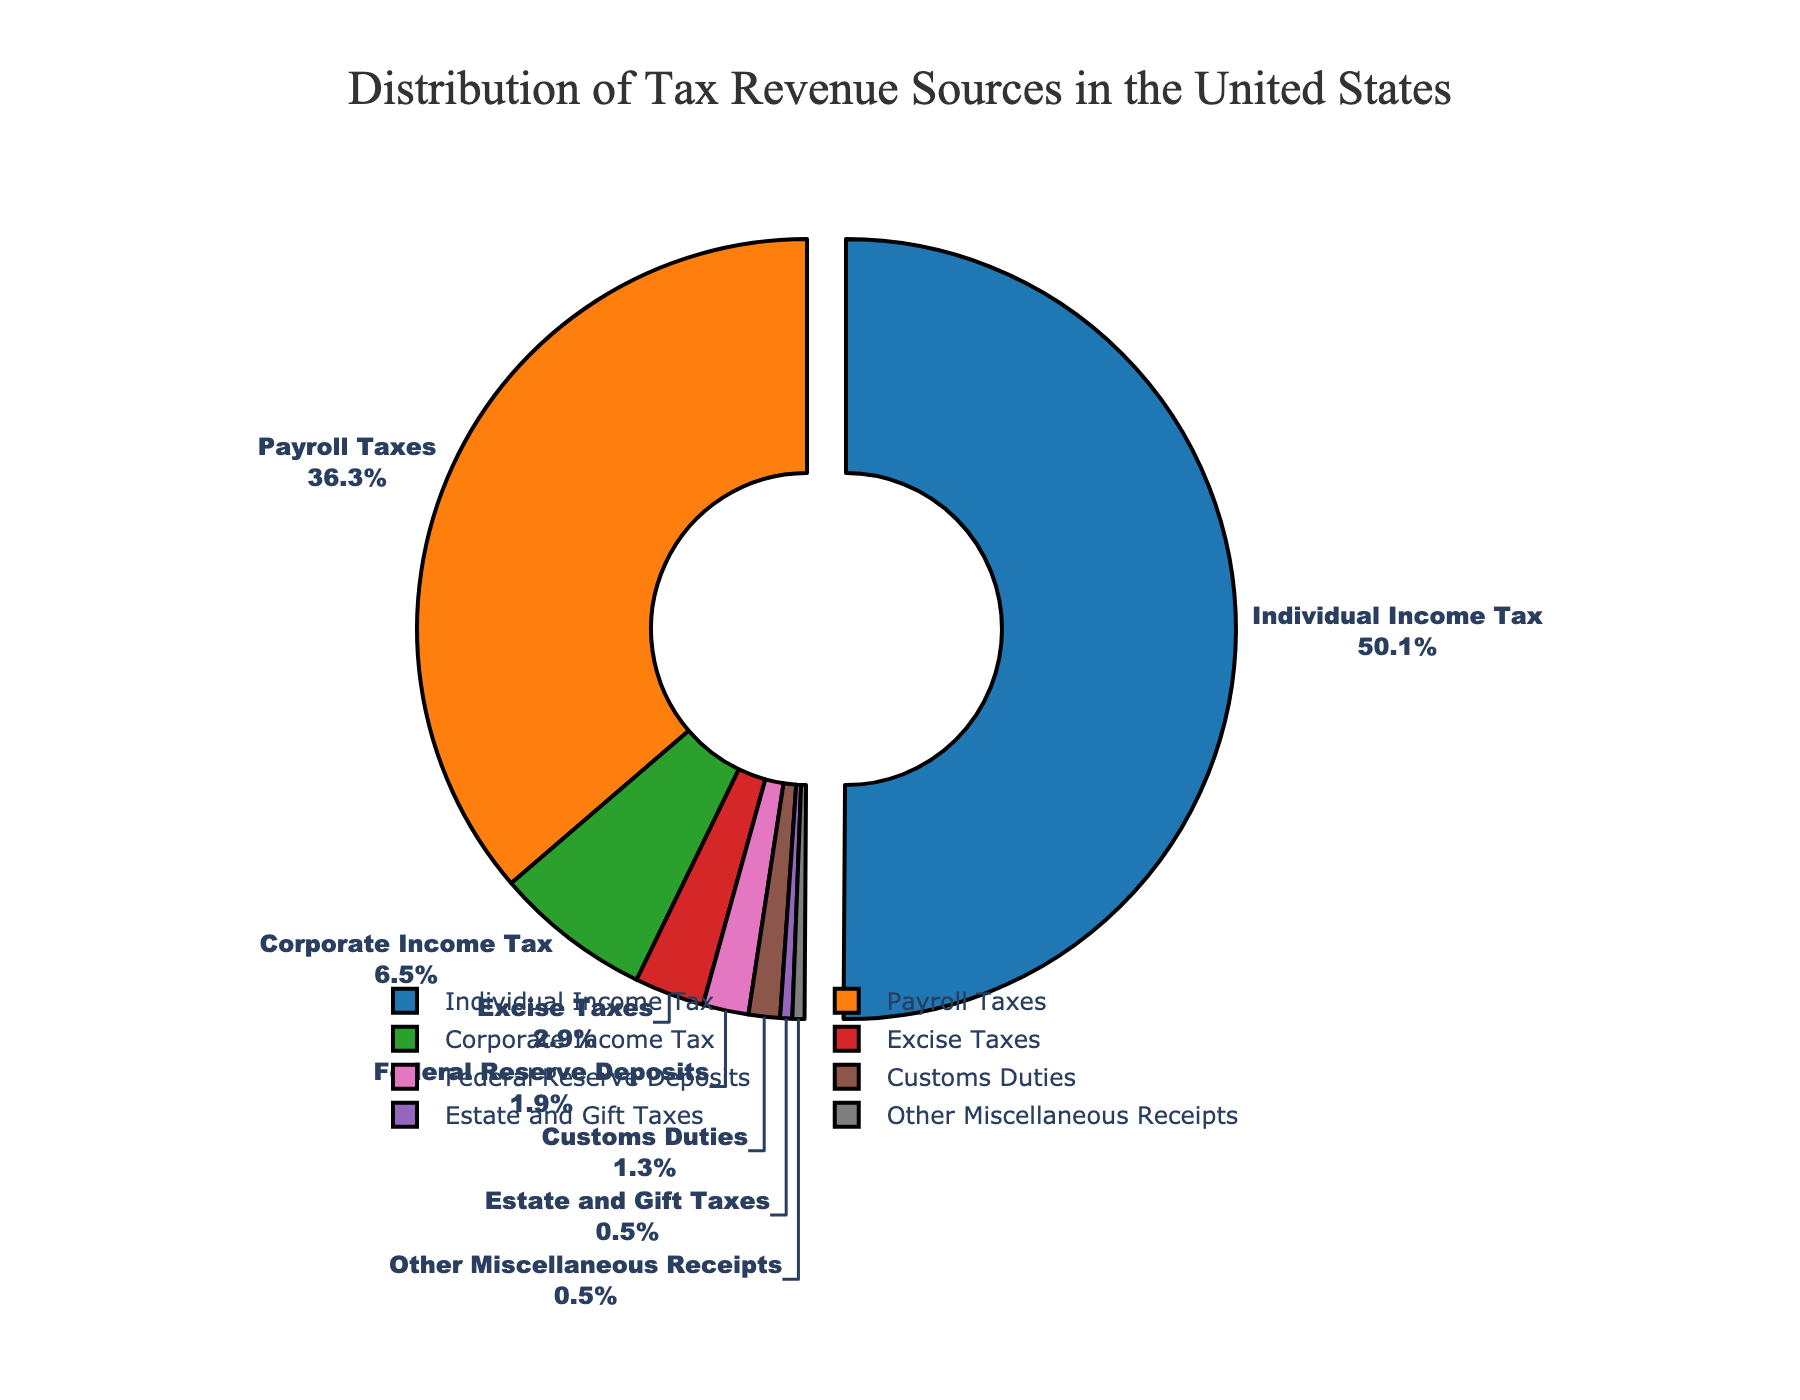What is the largest source of tax revenue? By referring to the pie chart, the segment with the largest portion will be the largest source. The 'Individual Income Tax' segment is visually the largest in the pie chart.
Answer: Individual Income Tax What percentage of tax revenue comes from Payroll Taxes? The visual information shows a segment labeled 'Payroll Taxes' with a percentage. This segment is 36.3%.
Answer: 36.3% How much larger is the Corporate Income Tax compared to Excise Taxes? Looking at the pie chart, find the segments for 'Corporate Income Tax' and 'Excise Taxes'. The percentages are 6.5% and 2.9%, respectively. Subtract the smaller percentage from the larger one: 6.5% - 2.9% = 3.6%.
Answer: 3.6% What is the combined percentage of tax revenue from Estate and Gift Taxes, and Other Miscellaneous Receipts? Locate each of the segments: 'Estate and Gift Taxes' and 'Other Miscellaneous Receipts.' Their percentages are 0.5% each. Adding them together gives: 0.5% + 0.5% = 1.0%.
Answer: 1.0% Is the percentage from Customs Duties higher or lower than Federal Reserve Deposits? Compare the segments for 'Customs Duties' and 'Federal Reserve Deposits'. Customs Duties is 1.3% while Federal Reserve Deposits is 1.9%. Since 1.3% is smaller than 1.9%, it is lower.
Answer: Lower Which source of revenue has the smallest contribution? By checking the pie chart, the smallest segment represents 'Estate and Gift Taxes' and 'Other Miscellaneous Receipts', both at 0.5%.
Answer: Estate and Gift Taxes, Other Miscellaneous Receipts What total percentage of tax revenue comes from taxes other than Individual Income Tax? The pie chart shows that Individual Income Tax is 50.1%. Subtract this from 100% to get the combined percentage of other taxes: 100% - 50.1% = 49.9%.
Answer: 49.9% How do Payroll Taxes compare to the sum of Corporate Income Tax and Excise Taxes? First, find the percentages: Payroll Taxes is 36.3%, Corporate Income Tax is 6.5%, and Excise Taxes is 2.9%. Add Corporate Income Tax and Excise Taxes: 6.5% + 2.9% = 9.4%. Compare this sum with Payroll Taxes: 36.3% > 9.4%.
Answer: Greater Which segment is visually pulled out of the pie chart, and why could that be? The 'Individual Income Tax' segment is displaced, indicating it is the largest contributor. Generally, this visual feature is used to emphasize significant data points.
Answer: Individual Income Tax 